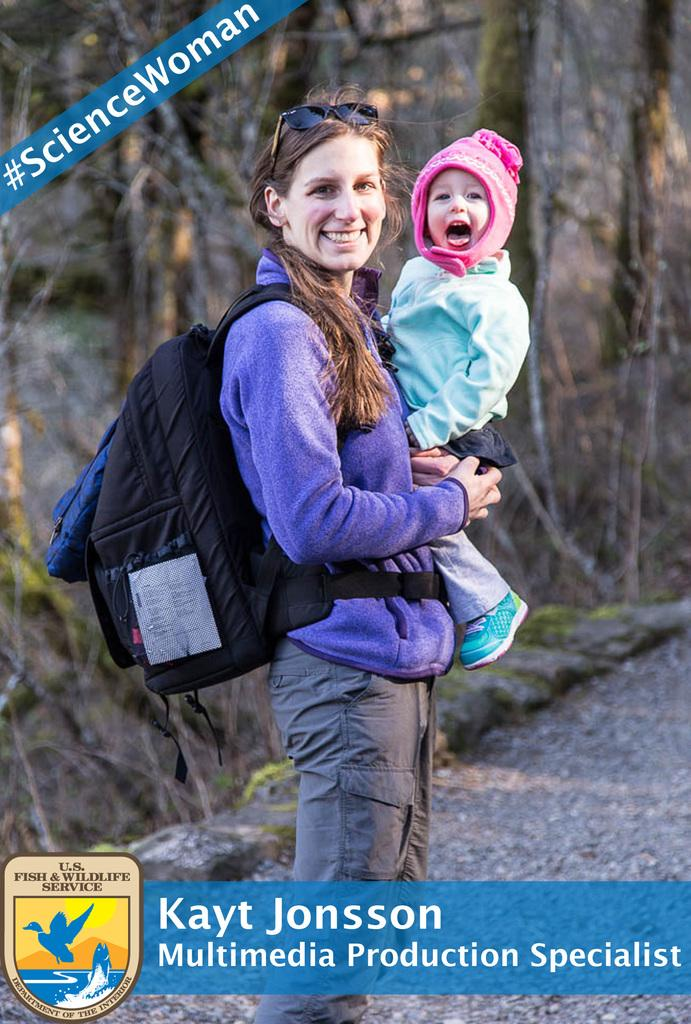What is featured in the image besides the woman and the kid? There is a poster in the image. What is the woman doing in the image? The woman is standing and smiling while carrying a kid. What can be found on the poster? There are words and a logo on the poster. How would you describe the background of the image? The background of the image is blurred. Can you see any kites flying in the image? There are no kites visible in the image. Where is the store located in the image? There is no store present in the image. 